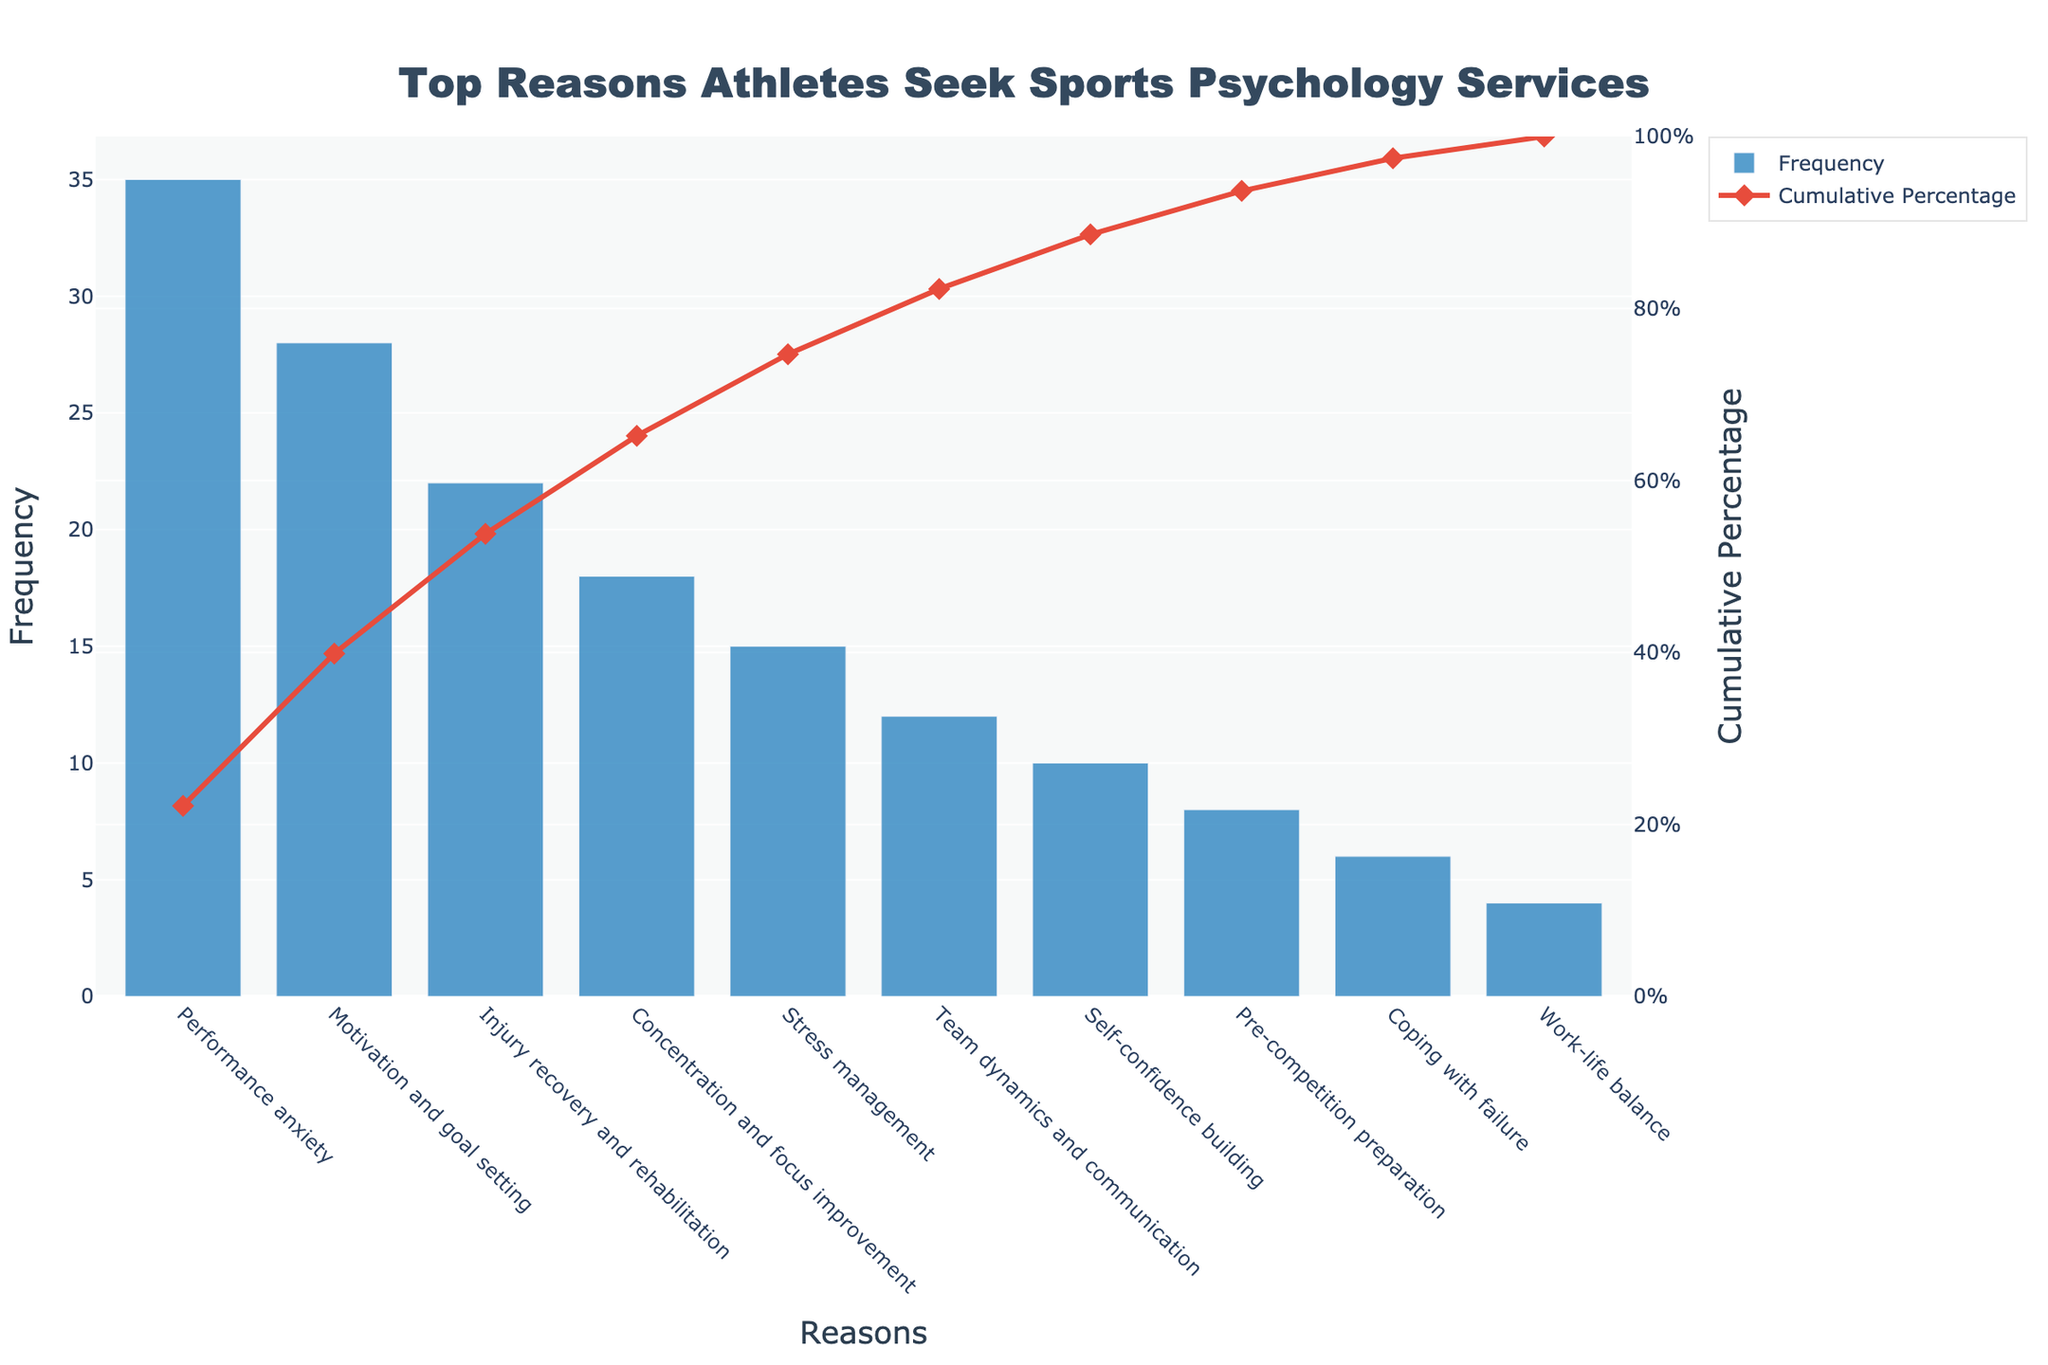What is the top reason athletes seek sports psychology services? By looking at the height of the bars on the chart, "Performance anxiety" has the highest frequency.
Answer: Performance anxiety What is the cumulative percentage for "Team dynamics and communication"? Locate "Team dynamics and communication" on the x-axis and trace upwards to the red line that indicates cumulative percentage, where it reaches approximately 86%.
Answer: 86% What is the second most frequent reason athletes seek sports psychology services? The second tallest bar after "Performance anxiety" belongs to "Motivation and goal setting".
Answer: Motivation and goal setting How many reasons have a cumulative percentage below 50%? Trace the cumulative percentage line and count the reasons until the percentage reaches 50%, which includes "Performance anxiety", "Motivation and goal setting", and "Injury recovery and rehabilitation" (a total of 3 reasons).
Answer: 3 reasons What is the difference in frequency between the top reason and the least frequent reason? Identify the frequencies of the top and least frequent reasons; "Performance anxiety" has 35, and "Work-life balance" has 4. The difference is 35 - 4 = 31.
Answer: 31 Which reason has the closest cumulative percentage to 75% and what is its frequency? Trace the cumulative percentage line near 75%, which closely corresponds to "Stress management". The frequency for "Stress management" is 15.
Answer: Stress management, 15 How many reasons have a frequency of 10 or less? Count all bars with heights 10 or less: "Self-confidence building" (10), "Pre-competition preparation" (8), "Coping with failure" (6), and "Work-life balance" (4). A total of 4 reasons meet the criteria.
Answer: 4 reasons What is the cumulative percentage for the top three most frequent reasons combined? Add the individual cumulative percentages for "Performance anxiety" (35), "Motivation and goal setting" (28), and "Injury recovery and rehabilitation" (22). The sum is (35 + 28 + 22) = 85.0%, as shown in the chart.
Answer: 85% Between "Concentration and focus improvement" and "Stress management", which has a higher frequency and by how much? "Concentration and focus improvement" has a frequency of 18, and "Stress management" has a frequency of 15. The difference is 18 - 15 = 3.
Answer: Concentration and focus improvement, 3 What is the combined frequency of the four least frequent reasons? Sum the frequencies of "Work-life balance" (4), "Coping with failure" (6), "Pre-competition preparation" (8), and "Self-confidence building" (10). The combined frequency is 4 + 6 + 8 + 10 = 28.
Answer: 28 